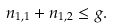<formula> <loc_0><loc_0><loc_500><loc_500>n _ { 1 , 1 } + n _ { 1 , 2 } \leq g .</formula> 